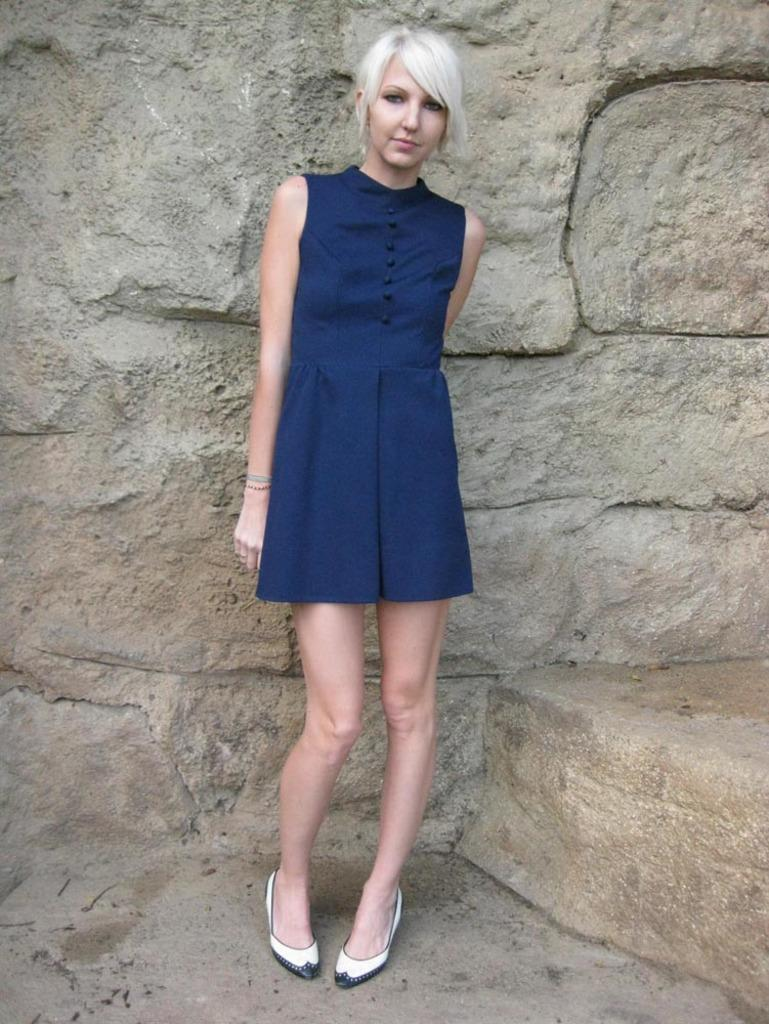Who is present in the image? There is a woman in the image. What is the woman wearing? The woman is wearing a blue dress. What type of footwear is the woman wearing? The woman is wearing shoes. What can be seen in the background of the image? There is a rock in the background of the image. What type of bun is the woman holding in the image? There is no bun present in the image; the woman is not holding any food item. Can you describe the dog that is sitting next to the woman in the image? There is no dog present in the image; only the woman and the rock in the background can be seen. 